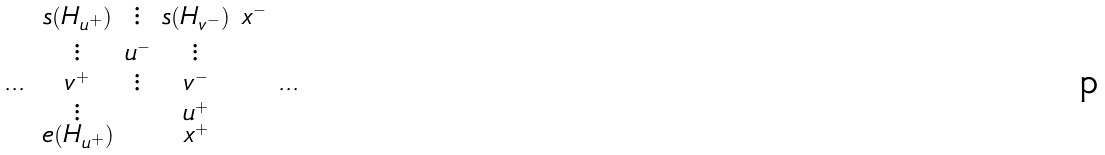Convert formula to latex. <formula><loc_0><loc_0><loc_500><loc_500>\begin{smallmatrix} & s ( H _ { u ^ { + } } ) & \vdots & s ( H _ { v ^ { - } } ) & x ^ { - } & \\ & \vdots & u ^ { - } & \vdots & & \\ \dots & v ^ { + } & \vdots & v ^ { - } & & \dots \\ & \vdots & & u ^ { + } \\ & e ( H _ { u ^ { + } } ) & & x ^ { + } \\ & & \\ & & \end{smallmatrix}</formula> 